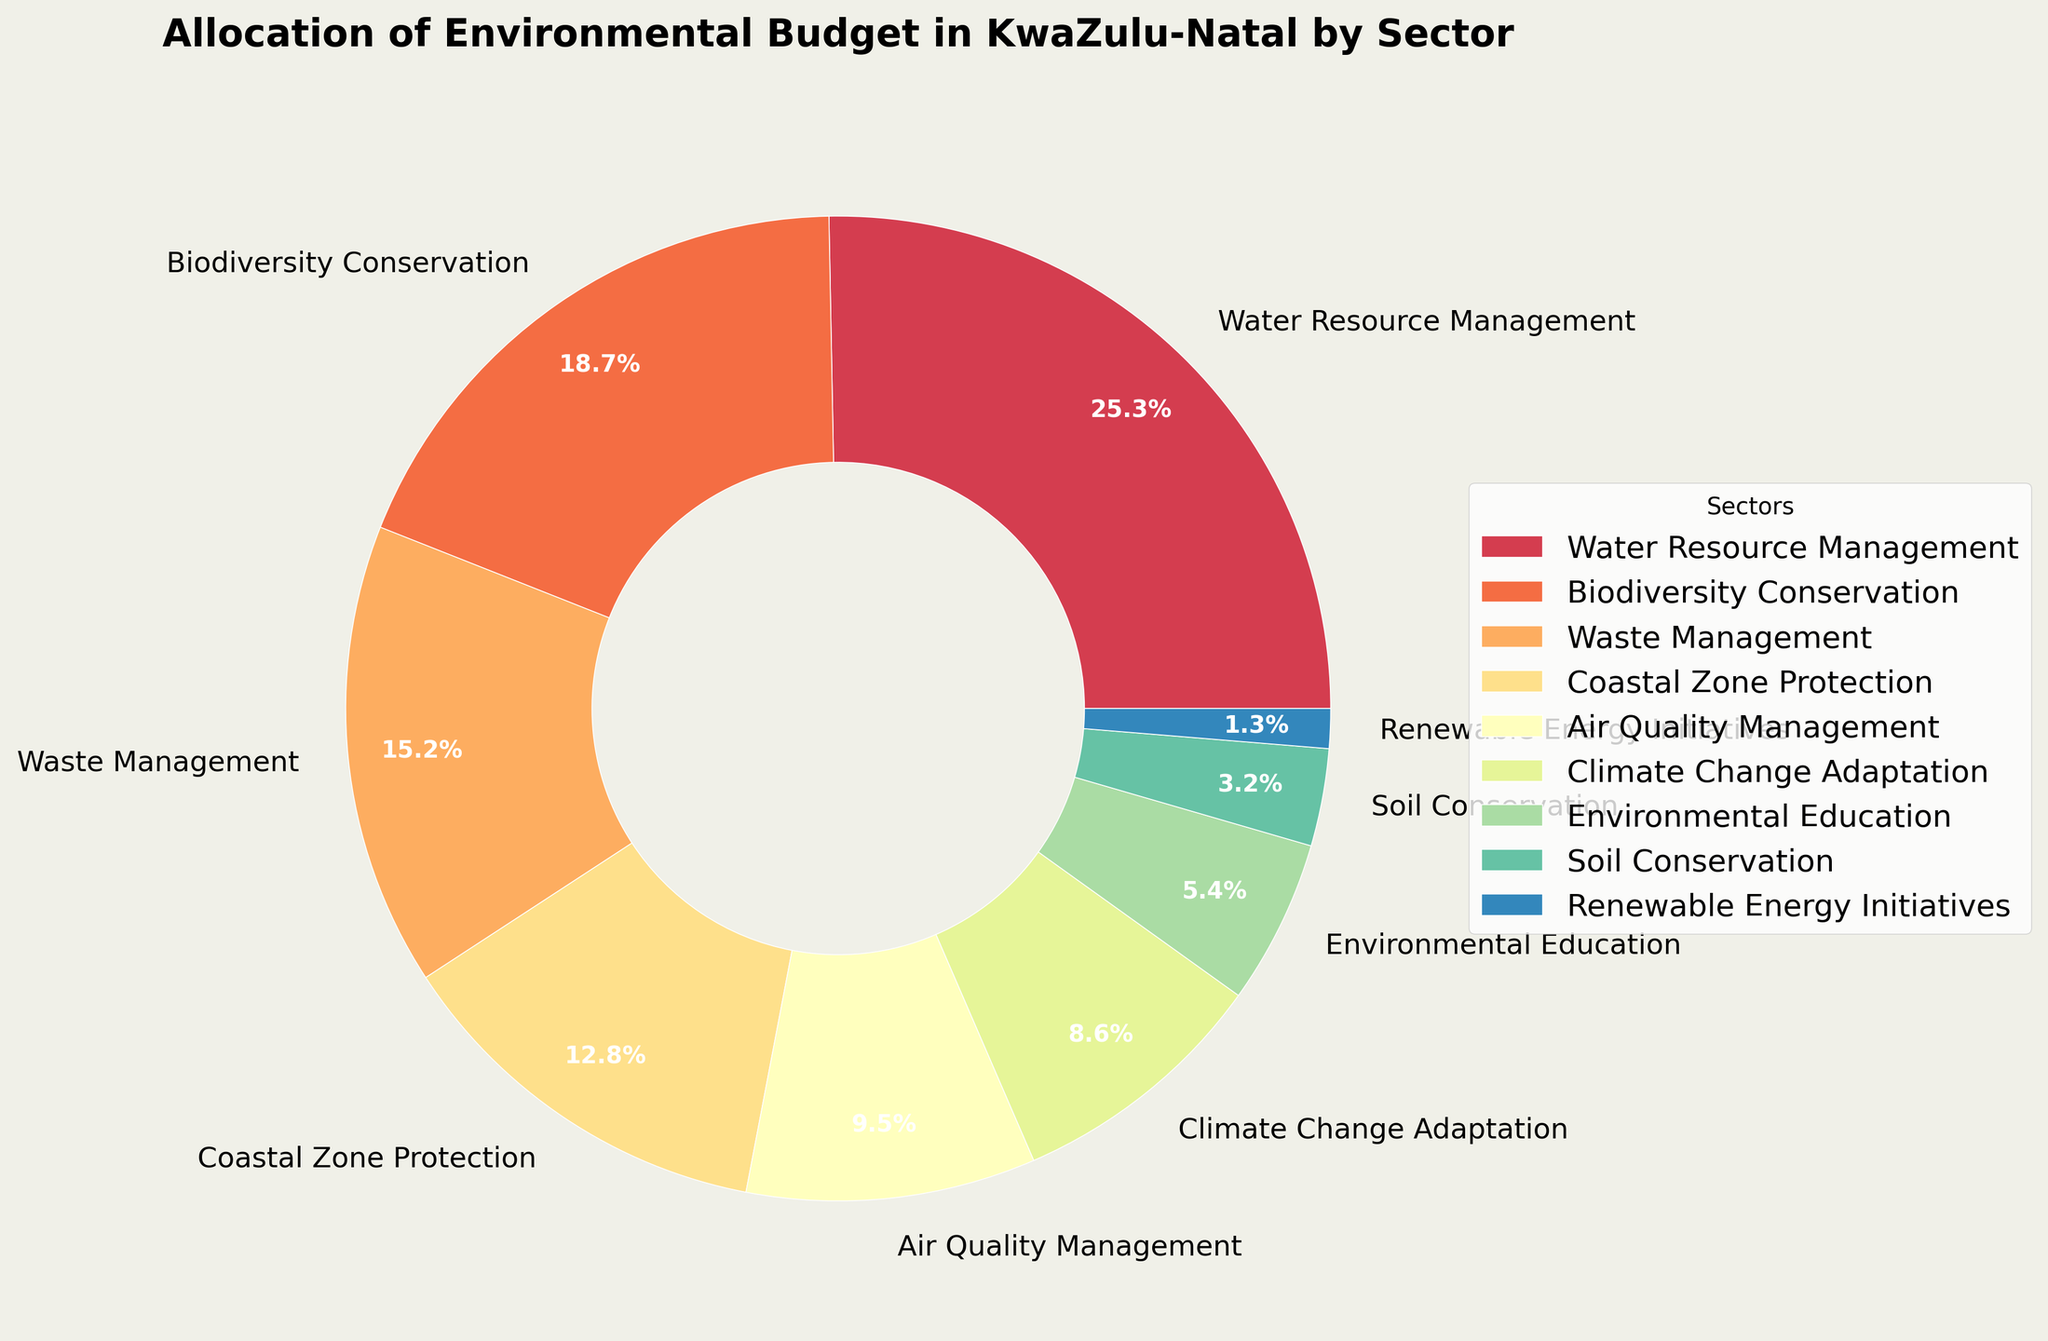Which sector has the highest budget allocation? The slice with the largest size in the pie chart represents the sector with the highest budget allocation.
Answer: Water Resource Management How much more budget allocation does Water Resource Management have compared to Coastal Zone Protection? Water Resource Management has 25.3%, and Coastal Zone Protection has 12.8%. The difference is calculated as 25.3% - 12.8% = 12.5%.
Answer: 12.5% What is the combined budget allocation for Biodiversity Conservation and Waste Management? The budget allocations for Biodiversity Conservation and Waste Management are 18.7% and 15.2%, respectively. The combined allocation is 18.7% + 15.2% = 33.9%.
Answer: 33.9% Which sector has the smallest budget allocation, and what is its percentage? The smallest slice in the pie chart represents the sector with the smallest budget allocation, which is Renewable Energy Initiatives, with a budget allocation of 1.3%.
Answer: Renewable Energy Initiatives, 1.3% Are there more sectors with a budget allocation above or below 10%? Sectors with a budget allocation above 10% are Water Resource Management, Biodiversity Conservation, Waste Management, and Coastal Zone Protection (4 sectors). Sectors below 10% are Air Quality Management, Climate Change Adaptation, Environmental Education, Soil Conservation, and Renewable Energy Initiatives (5 sectors).
Answer: Below How does the budget allocation of Air Quality Management compare to that of Soil Conservation? Air Quality Management has a budget allocation of 9.5%, while Soil Conservation has 3.2%. 9.5% is greater than 3.2%.
Answer: Air Quality Management has a higher allocation What is the average budget allocation across all sectors? Add up all the budget allocations (25.3 + 18.7 + 15.2 + 12.8 + 9.5 + 8.6 + 5.4 + 3.2 + 1.3 = 100). Since there are 9 sectors, the average allocation is 100 / 9.
Answer: 11.1% What percentage of the budget is allocated to sectors related to climate change (Climate Change Adaptation and Renewable Energy Initiatives)? The budget allocations are 8.6% for Climate Change Adaptation and 1.3% for Renewable Energy Initiatives. The combined allocation is 8.6% + 1.3% = 9.9%.
Answer: 9.9% Is the budget for Coastal Zone Protection higher than that for Waste Management? Coastal Zone Protection has a budget allocation of 12.8%, while Waste Management has 15.2%. Thus, 12.8% is less than 15.2%.
Answer: No Which has a greater budget allocation: Environmental Education or Air Quality Management? Environmental Education has 5.4%, and Air Quality Management has 9.5%. 9.5% is greater than 5.4%.
Answer: Air Quality Management 